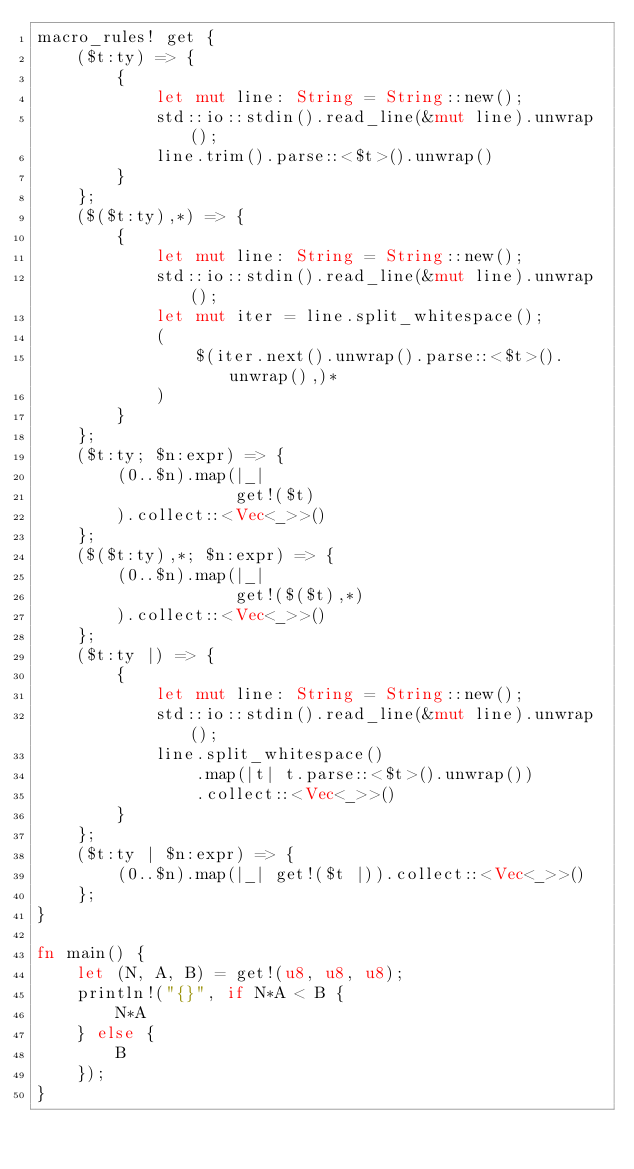Convert code to text. <code><loc_0><loc_0><loc_500><loc_500><_Rust_>macro_rules! get {
    ($t:ty) => {
        {
            let mut line: String = String::new();
            std::io::stdin().read_line(&mut line).unwrap();
            line.trim().parse::<$t>().unwrap()
        }
    };
    ($($t:ty),*) => {
        {
            let mut line: String = String::new();
            std::io::stdin().read_line(&mut line).unwrap();
            let mut iter = line.split_whitespace();
            (
                $(iter.next().unwrap().parse::<$t>().unwrap(),)*
            )
        }
    };
    ($t:ty; $n:expr) => {
        (0..$n).map(|_|
                    get!($t)
        ).collect::<Vec<_>>()
    };
    ($($t:ty),*; $n:expr) => {
        (0..$n).map(|_|
                    get!($($t),*)
        ).collect::<Vec<_>>()
    };
    ($t:ty |) => {
        {
            let mut line: String = String::new();
            std::io::stdin().read_line(&mut line).unwrap();
            line.split_whitespace()
                .map(|t| t.parse::<$t>().unwrap())
                .collect::<Vec<_>>()
        }
    };
    ($t:ty | $n:expr) => {
        (0..$n).map(|_| get!($t |)).collect::<Vec<_>>()
    };
}

fn main() {
    let (N, A, B) = get!(u8, u8, u8);
    println!("{}", if N*A < B {
        N*A 
    } else {
        B
    });
}
</code> 